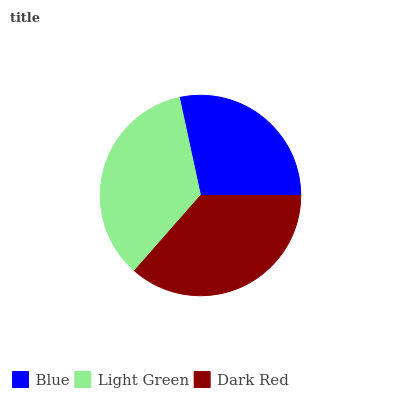Is Blue the minimum?
Answer yes or no. Yes. Is Dark Red the maximum?
Answer yes or no. Yes. Is Light Green the minimum?
Answer yes or no. No. Is Light Green the maximum?
Answer yes or no. No. Is Light Green greater than Blue?
Answer yes or no. Yes. Is Blue less than Light Green?
Answer yes or no. Yes. Is Blue greater than Light Green?
Answer yes or no. No. Is Light Green less than Blue?
Answer yes or no. No. Is Light Green the high median?
Answer yes or no. Yes. Is Light Green the low median?
Answer yes or no. Yes. Is Blue the high median?
Answer yes or no. No. Is Dark Red the low median?
Answer yes or no. No. 